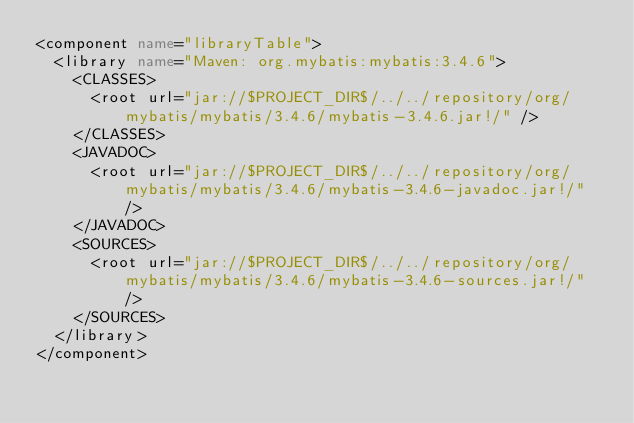<code> <loc_0><loc_0><loc_500><loc_500><_XML_><component name="libraryTable">
  <library name="Maven: org.mybatis:mybatis:3.4.6">
    <CLASSES>
      <root url="jar://$PROJECT_DIR$/../../repository/org/mybatis/mybatis/3.4.6/mybatis-3.4.6.jar!/" />
    </CLASSES>
    <JAVADOC>
      <root url="jar://$PROJECT_DIR$/../../repository/org/mybatis/mybatis/3.4.6/mybatis-3.4.6-javadoc.jar!/" />
    </JAVADOC>
    <SOURCES>
      <root url="jar://$PROJECT_DIR$/../../repository/org/mybatis/mybatis/3.4.6/mybatis-3.4.6-sources.jar!/" />
    </SOURCES>
  </library>
</component></code> 